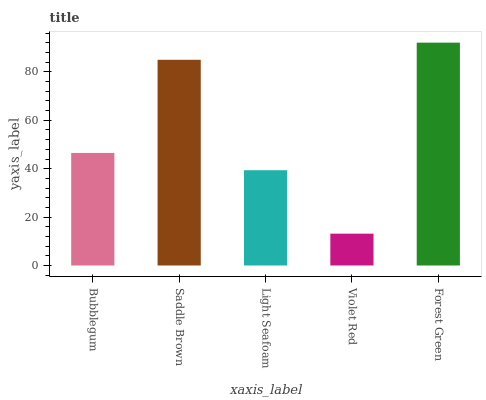Is Violet Red the minimum?
Answer yes or no. Yes. Is Forest Green the maximum?
Answer yes or no. Yes. Is Saddle Brown the minimum?
Answer yes or no. No. Is Saddle Brown the maximum?
Answer yes or no. No. Is Saddle Brown greater than Bubblegum?
Answer yes or no. Yes. Is Bubblegum less than Saddle Brown?
Answer yes or no. Yes. Is Bubblegum greater than Saddle Brown?
Answer yes or no. No. Is Saddle Brown less than Bubblegum?
Answer yes or no. No. Is Bubblegum the high median?
Answer yes or no. Yes. Is Bubblegum the low median?
Answer yes or no. Yes. Is Violet Red the high median?
Answer yes or no. No. Is Violet Red the low median?
Answer yes or no. No. 